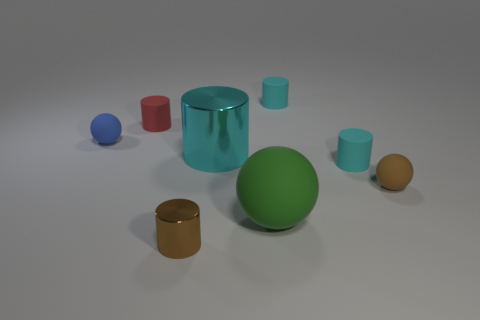Subtract all big green rubber balls. How many balls are left? 2 Add 1 tiny brown matte spheres. How many objects exist? 9 Subtract all brown cylinders. How many cylinders are left? 4 Subtract all cylinders. How many objects are left? 3 Subtract 1 cylinders. How many cylinders are left? 4 Subtract all small shiny cylinders. Subtract all tiny brown rubber things. How many objects are left? 6 Add 1 big cyan things. How many big cyan things are left? 2 Add 7 small yellow rubber objects. How many small yellow rubber objects exist? 7 Subtract 0 blue cubes. How many objects are left? 8 Subtract all red balls. Subtract all green blocks. How many balls are left? 3 